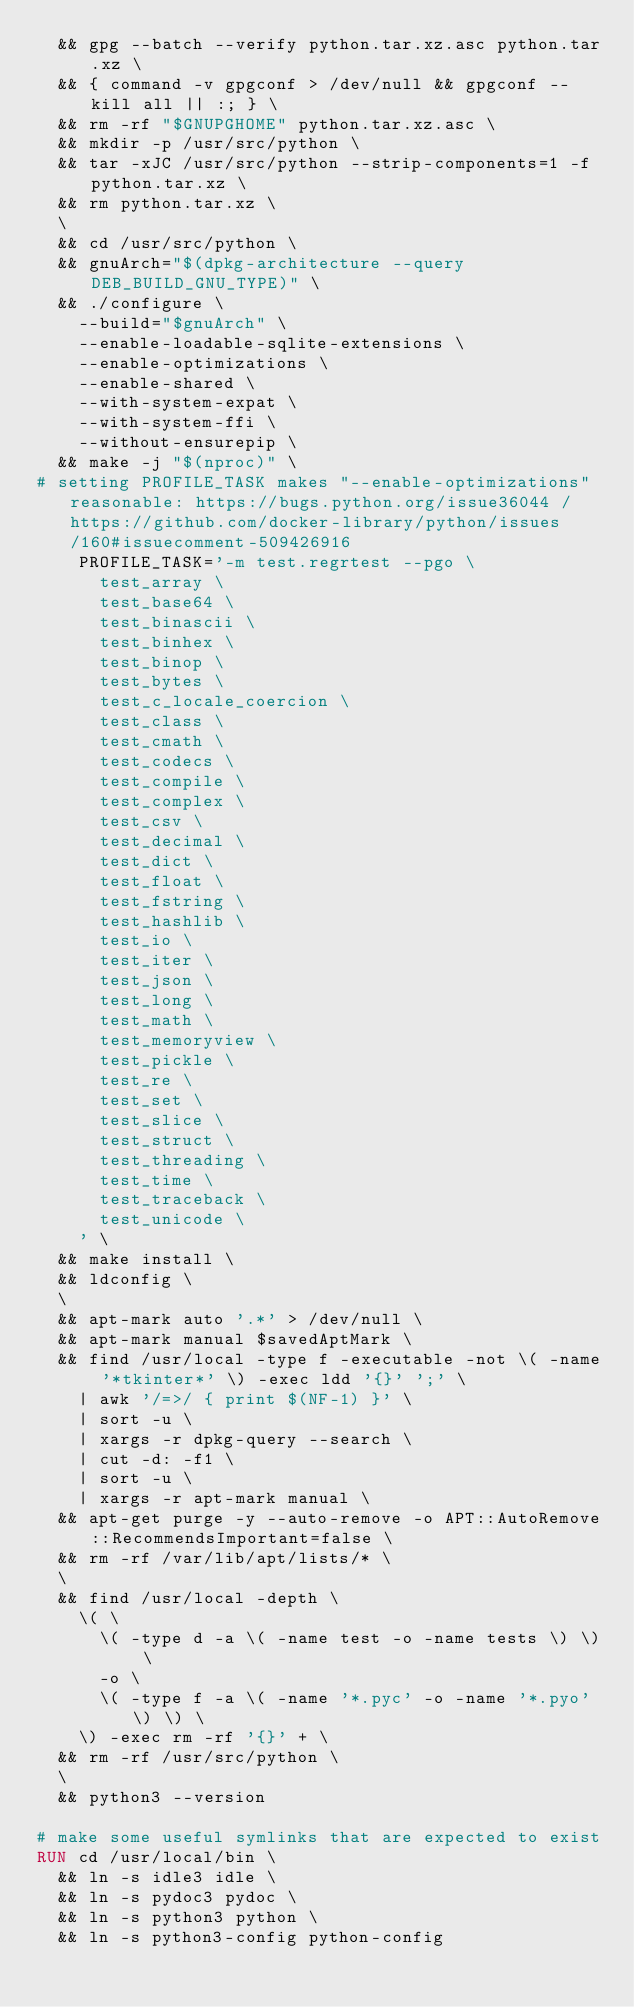<code> <loc_0><loc_0><loc_500><loc_500><_Dockerfile_>	&& gpg --batch --verify python.tar.xz.asc python.tar.xz \
	&& { command -v gpgconf > /dev/null && gpgconf --kill all || :; } \
	&& rm -rf "$GNUPGHOME" python.tar.xz.asc \
	&& mkdir -p /usr/src/python \
	&& tar -xJC /usr/src/python --strip-components=1 -f python.tar.xz \
	&& rm python.tar.xz \
	\
	&& cd /usr/src/python \
	&& gnuArch="$(dpkg-architecture --query DEB_BUILD_GNU_TYPE)" \
	&& ./configure \
		--build="$gnuArch" \
		--enable-loadable-sqlite-extensions \
		--enable-optimizations \
		--enable-shared \
		--with-system-expat \
		--with-system-ffi \
		--without-ensurepip \
	&& make -j "$(nproc)" \
# setting PROFILE_TASK makes "--enable-optimizations" reasonable: https://bugs.python.org/issue36044 / https://github.com/docker-library/python/issues/160#issuecomment-509426916
		PROFILE_TASK='-m test.regrtest --pgo \
			test_array \
			test_base64 \
			test_binascii \
			test_binhex \
			test_binop \
			test_bytes \
			test_c_locale_coercion \
			test_class \
			test_cmath \
			test_codecs \
			test_compile \
			test_complex \
			test_csv \
			test_decimal \
			test_dict \
			test_float \
			test_fstring \
			test_hashlib \
			test_io \
			test_iter \
			test_json \
			test_long \
			test_math \
			test_memoryview \
			test_pickle \
			test_re \
			test_set \
			test_slice \
			test_struct \
			test_threading \
			test_time \
			test_traceback \
			test_unicode \
		' \
	&& make install \
	&& ldconfig \
	\
	&& apt-mark auto '.*' > /dev/null \
	&& apt-mark manual $savedAptMark \
	&& find /usr/local -type f -executable -not \( -name '*tkinter*' \) -exec ldd '{}' ';' \
		| awk '/=>/ { print $(NF-1) }' \
		| sort -u \
		| xargs -r dpkg-query --search \
		| cut -d: -f1 \
		| sort -u \
		| xargs -r apt-mark manual \
	&& apt-get purge -y --auto-remove -o APT::AutoRemove::RecommendsImportant=false \
	&& rm -rf /var/lib/apt/lists/* \
	\
	&& find /usr/local -depth \
		\( \
			\( -type d -a \( -name test -o -name tests \) \) \
			-o \
			\( -type f -a \( -name '*.pyc' -o -name '*.pyo' \) \) \
		\) -exec rm -rf '{}' + \
	&& rm -rf /usr/src/python \
	\
	&& python3 --version

# make some useful symlinks that are expected to exist
RUN cd /usr/local/bin \
	&& ln -s idle3 idle \
	&& ln -s pydoc3 pydoc \
	&& ln -s python3 python \
	&& ln -s python3-config python-config
</code> 